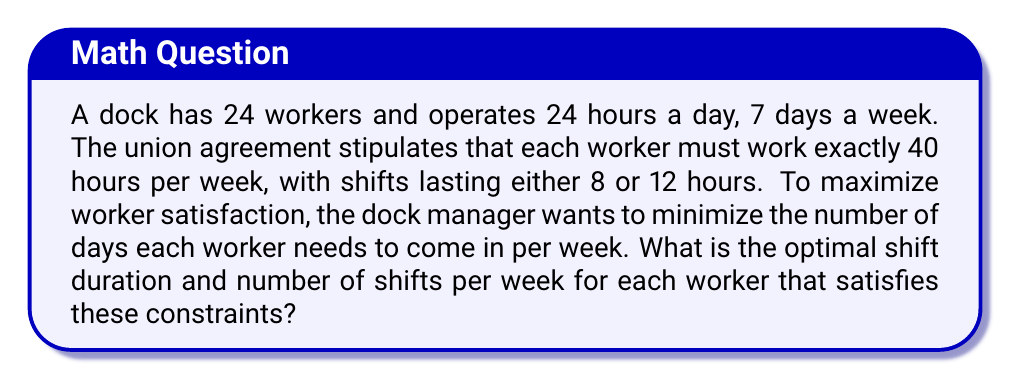Teach me how to tackle this problem. To solve this problem, we need to consider the following:

1. Total work hours per week: 40 hours
2. Possible shift durations: 8 hours or 12 hours

Let's analyze both scenarios:

Scenario 1: 8-hour shifts
* Number of shifts per week: $\frac{40 \text{ hours}}{8 \text{ hours/shift}} = 5$ shifts
* Number of days worked: 5 days

Scenario 2: 12-hour shifts
* Number of shifts per week: $\frac{40 \text{ hours}}{12 \text{ hours/shift}} = 3.33$ shifts

Since we can't have fractional shifts, we need to round up to 4 shifts to meet the 40-hour requirement.

* Number of days worked: 4 days
* Total hours worked: $4 \times 12 = 48$ hours

However, this exceeds the 40-hour requirement. To address this, we can adjust the shift duration:

* Adjusted shift duration: $\frac{40 \text{ hours}}{4 \text{ shifts}} = 10$ hours per shift

Therefore, the optimal solution is:
* Shift duration: 10 hours
* Number of shifts per week: 4
* Number of days worked: 4 days

This satisfies the 40-hour work week requirement and minimizes the number of days each worker needs to come in, thus maximizing worker satisfaction.
Answer: The optimal shift schedule is 4 shifts of 10 hours each per week, resulting in workers coming in for 4 days per week. 